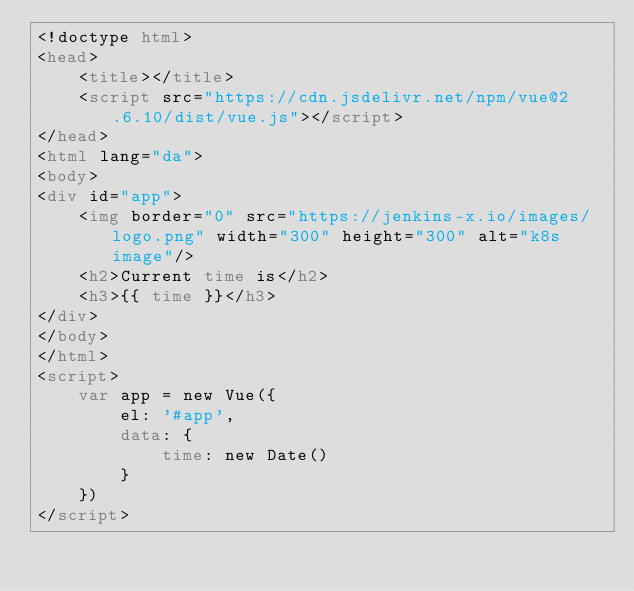<code> <loc_0><loc_0><loc_500><loc_500><_HTML_><!doctype html>
<head>
    <title></title>
    <script src="https://cdn.jsdelivr.net/npm/vue@2.6.10/dist/vue.js"></script>
</head>
<html lang="da">
<body>
<div id="app">
    <img border="0" src="https://jenkins-x.io/images/logo.png" width="300" height="300" alt="k8s image"/>
    <h2>Current time is</h2>
    <h3>{{ time }}</h3>
</div>
</body>
</html>
<script>
    var app = new Vue({
        el: '#app',
        data: {
            time: new Date()
        }
    })
</script>
</code> 